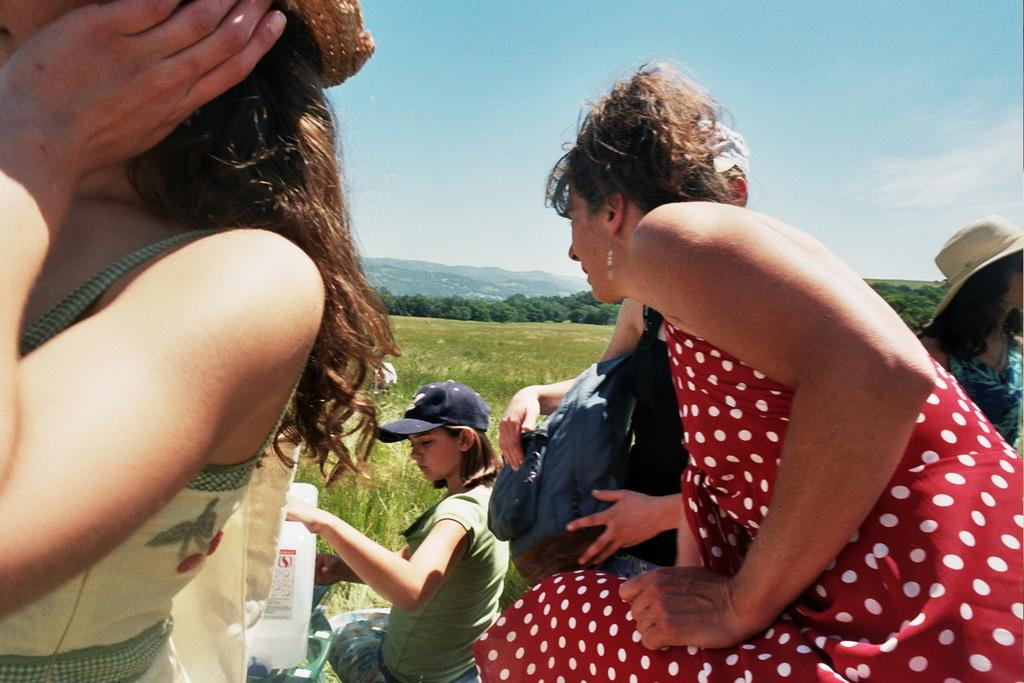Who or what can be seen in the image? There are people in the image. What type of surface is visible in the image? There is grass on the surface in the image. What can be seen in the background of the image? There are trees, mountains, and the sky visible in the background of the image. What type of sponge is being used by the writer in the image? There is no writer or sponge present in the image. 